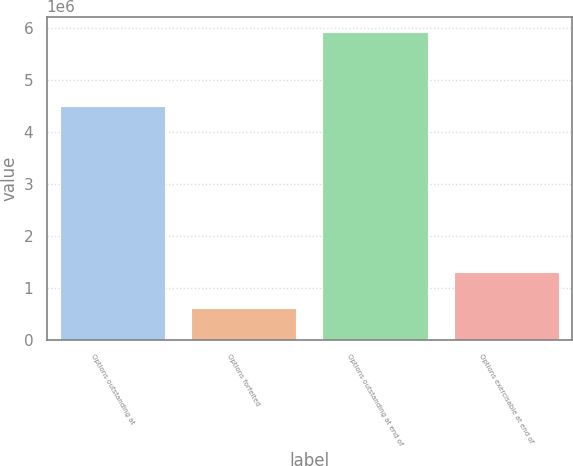Convert chart to OTSL. <chart><loc_0><loc_0><loc_500><loc_500><bar_chart><fcel>Options outstanding at<fcel>Options forfeited<fcel>Options outstanding at end of<fcel>Options exercisable at end of<nl><fcel>4.50906e+06<fcel>614000<fcel>5.93206e+06<fcel>1.29661e+06<nl></chart> 